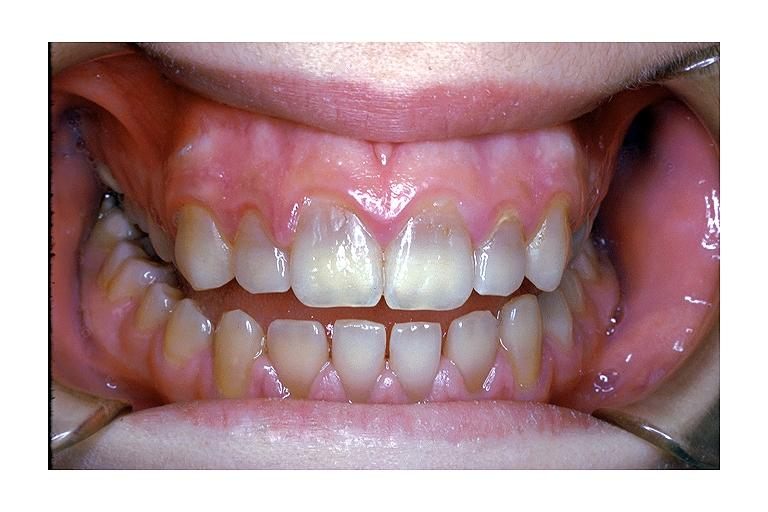what is tetracycline induced?
Answer the question using a single word or phrase. Discoloration 